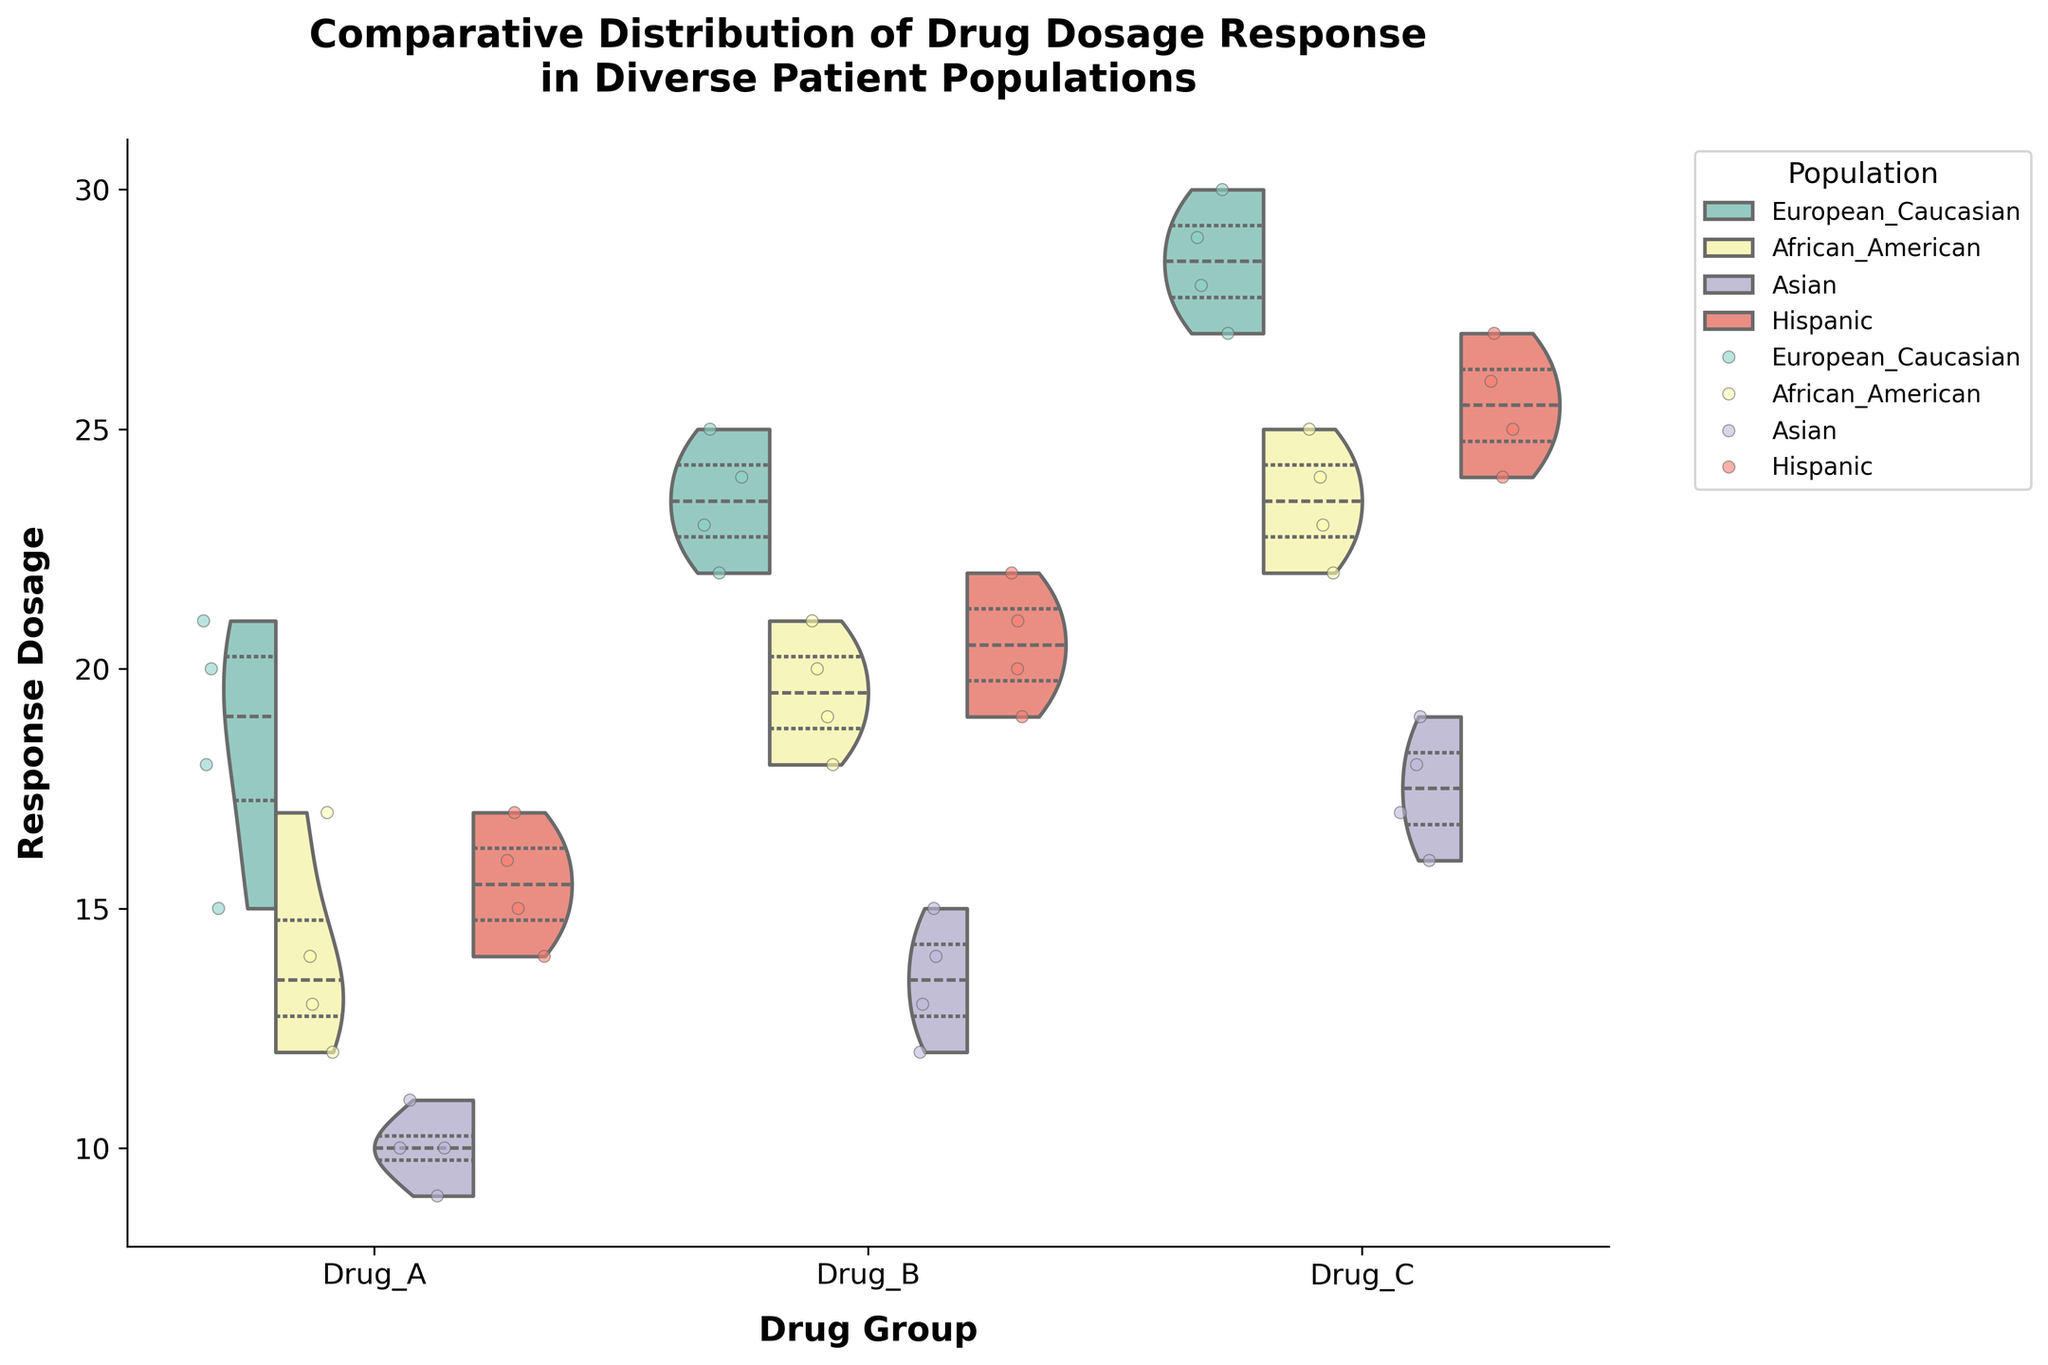What's the title of the figure? The title of the figure is displayed at the top and summarizes the overall content. It reads: "Comparative Distribution of Drug Dosage Response in Diverse Patient Populations."
Answer: Comparative Distribution of Drug Dosage Response in Diverse Patient Populations How many drug groups are represented in the figure? The x-axis categorizes the data into groups. There are three drug groups shown: Drug_A, Drug_B, and Drug_C.
Answer: Three Which population has the greatest spread of dosage response for Drug_A? We can assess the spread by observing the width of the violin plot for each population within Drug_A. The European_Caucasian group shows a wider spread compared to others.
Answer: European_Caucasian What is the median dosage for Drug_B among Asian populations? The inner quartile lines of the violin plots represent the median. For the Asian population in Drug_B, the median line is at 13.5.
Answer: 13.5 Which population shows the highest average dosage response for Drug_C? By looking at the quartile lines and the density of points centered around them, the European_Caucasian population shows the highest average dosage.
Answer: European_Caucasian Compare the interquartile range (IQR) of Drug_B responses between European_Caucasian and Hispanic populations. The IQR is represented by the width of the violin plot between the first and third quartiles. Hispanic population for Drug_B has a narrower IQR (around 19 to 22) compared to the European_Caucasian (around 22 to 25).
Answer: Hispanic has a narrower IQR Which drug group shows the least variation in response for the African_American population? The violin plot's width represents variation. Drug_A and Drug_B show more consistent (less varied) dosage responses for the African_American population compared to Drug_C.
Answer: Drug_A In Drug_C, which population has the widest jittered points spread? Jittered points spread gives an intuitive sense of variability. For Drug_C, the Hispanic population shows a wider spread of jittered points compared to other populations.
Answer: Hispanic Compare the highest response dosage in the European_Caucasian population between Drug_A and Drug_B. The highest dosage in the European_Caucasian population is seen near the upper end of the violin plots: it’s close to 21 for Drug_A and approximately 25 for Drug_B.
Answer: Drug_B 